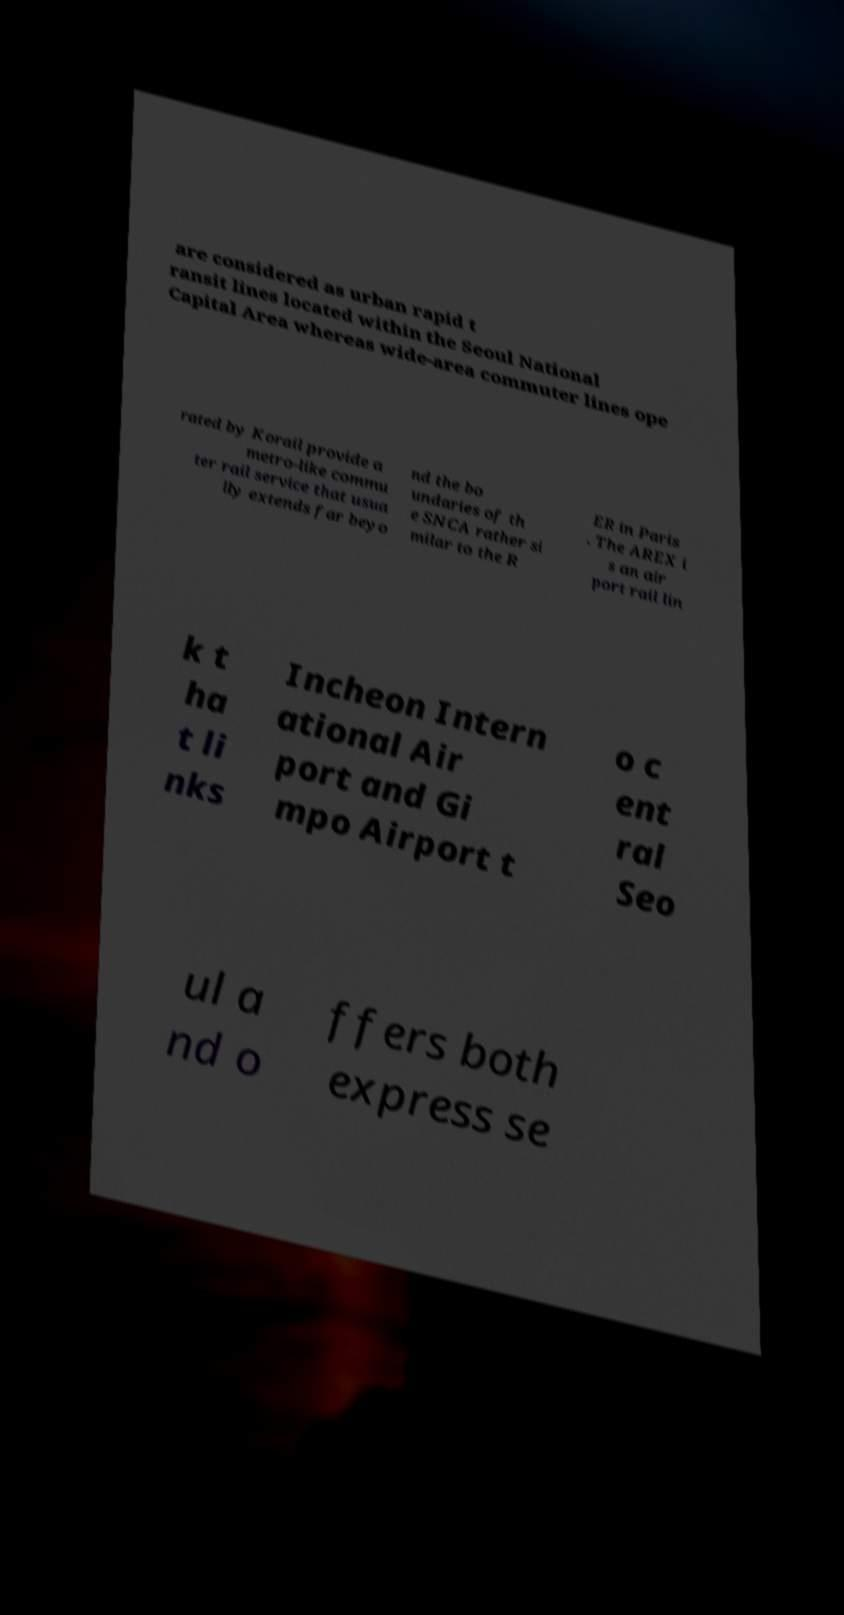Please read and relay the text visible in this image. What does it say? are considered as urban rapid t ransit lines located within the Seoul National Capital Area whereas wide-area commuter lines ope rated by Korail provide a metro-like commu ter rail service that usua lly extends far beyo nd the bo undaries of th e SNCA rather si milar to the R ER in Paris . The AREX i s an air port rail lin k t ha t li nks Incheon Intern ational Air port and Gi mpo Airport t o c ent ral Seo ul a nd o ffers both express se 